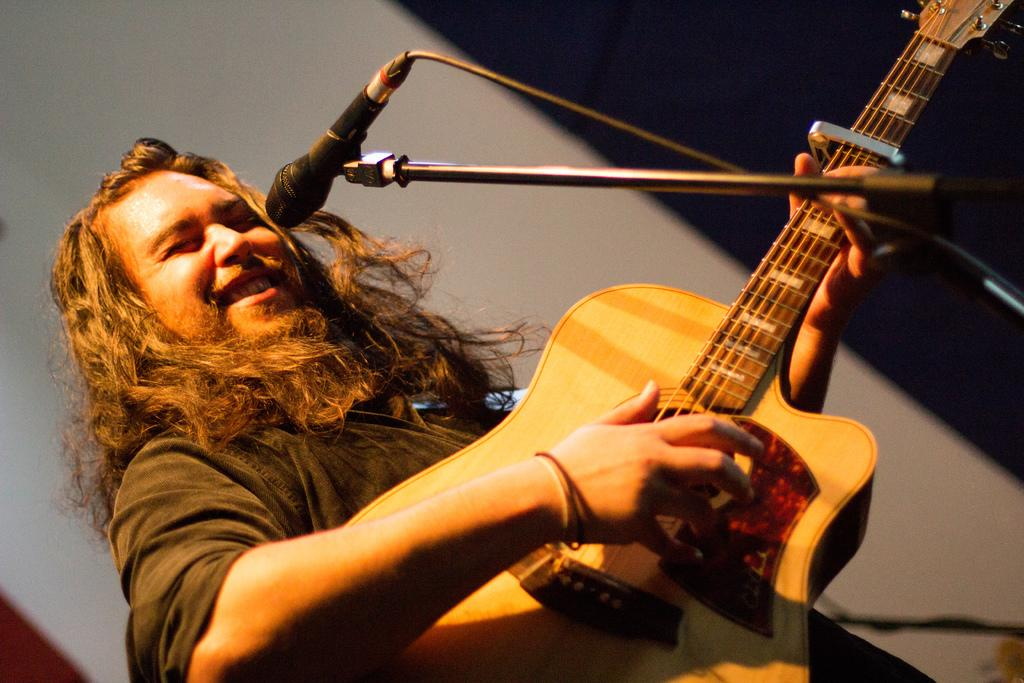What is the main subject of the image? There is a person in the image. What is the person doing in the image? The person is standing and playing a guitar. What is the person's facial expression in the image? The person is smiling in the image. What other objects are present in the image? There is a microphone and a microphone stand in the image. What type of kite is the person flying in the image? There is no kite present in the image; the person is playing a guitar. How many stones can be seen on the ground in the image? There is no mention of stones in the image; it features a person playing a guitar and other objects. 